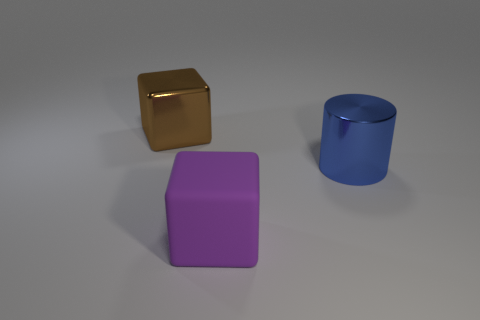Add 3 cyan metallic balls. How many objects exist? 6 Subtract all blocks. How many objects are left? 1 Subtract all purple objects. Subtract all blue cylinders. How many objects are left? 1 Add 3 shiny blocks. How many shiny blocks are left? 4 Add 1 large red matte things. How many large red matte things exist? 1 Subtract 1 brown cubes. How many objects are left? 2 Subtract all gray blocks. Subtract all green spheres. How many blocks are left? 2 